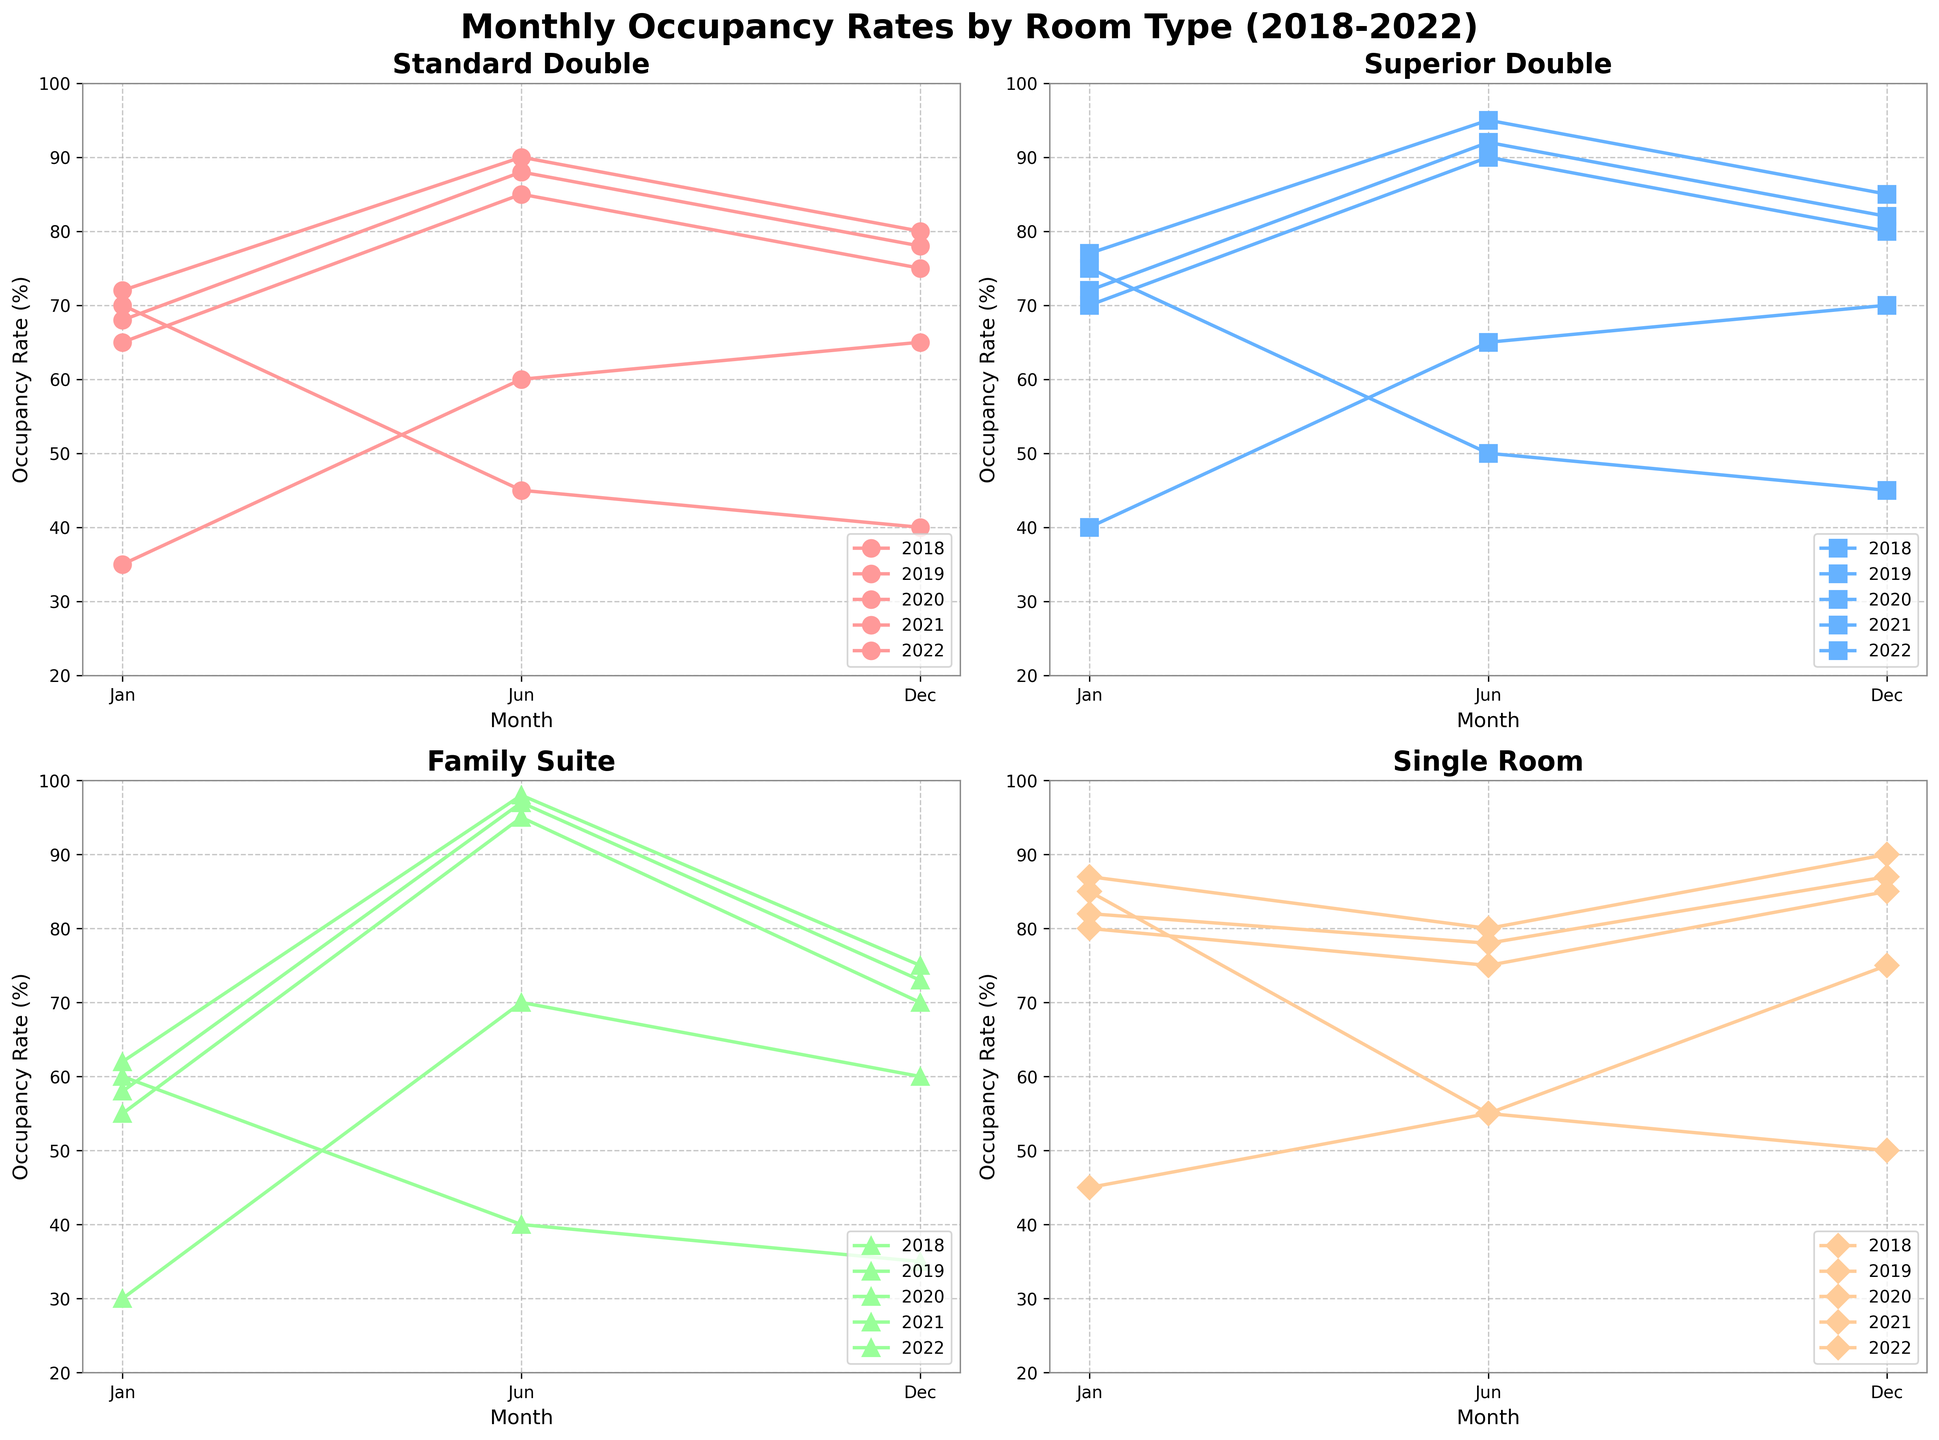What is the title of the figure? The title is typically located at the top of the figure and states the overall theme of the data being represented. In this case, the title is "Monthly Occupancy Rates by Room Type (2018-2022)."
Answer: Monthly Occupancy Rates by Room Type (2018-2022) Which room type has the highest occupancy rate in June 2022? To answer this, look for the data points representing June 2022 in each subplot. For instance, for Standard Double, it’s 90%; for Superior Double, it's 95%; for Family Suite, it's 98%; and for Single Room, it's 80%. The Family Suite has the highest occupancy rate.
Answer: Family Suite What is the overall trend for the Standard Double room occupancy in January over the years? Focus on the January data points of the Standard Double subplot for each year: 65% in 2018, 68% in 2019, 70% in 2020, 35% in 2021, and 72% in 2022. The trend shows an initial increase, a sharp drop in 2021, and then a recovery in 2022.
Answer: Increase, then decrease, then recovery Between which years does the Superior Double room show the most fluctuation in December? Analyze the December data points for Superior Double across the years: 80% in 2018, 82% in 2019, 45% in 2020, 70% in 2021, and 85% in 2022. The most fluctuation occurs between 2019 and 2020, where it drops from 82% to 45%.
Answer: 2019 and 2020 What can be inferred about the Family Suite room type during the pandemic (2020-2021)? For the Family Suite, the occupancy during the pandemic years (2020-2021) in January is 60% (2020) and 30% (2021), in June it's 40% (2020) and 70% (2021), and in December it's 35% (2020) and 60% (2021). The rates dropped significantly in 2020 and improved slightly in 2021.
Answer: Significant drop in 2020 and slight improvement in 2021 Which room type had the least variation in occupancy rates in January over the five years? Find the January occupancy rates for each room: Standard Double (65%, 68%, 70%, 35%, 72%), Superior Double (70%, 72%, 75%, 40%, 77%), Family Suite (55%, 58%, 60%, 30%, 62%), Single Room (80%, 82%, 85%, 45%, 87%). The Single Room shows the least variation.
Answer: Single Room 